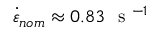Convert formula to latex. <formula><loc_0><loc_0><loc_500><loc_500>\dot { \varepsilon } _ { n o m } \approx 0 . 8 3 s ^ { - 1 }</formula> 